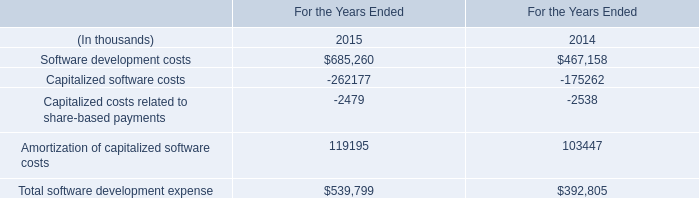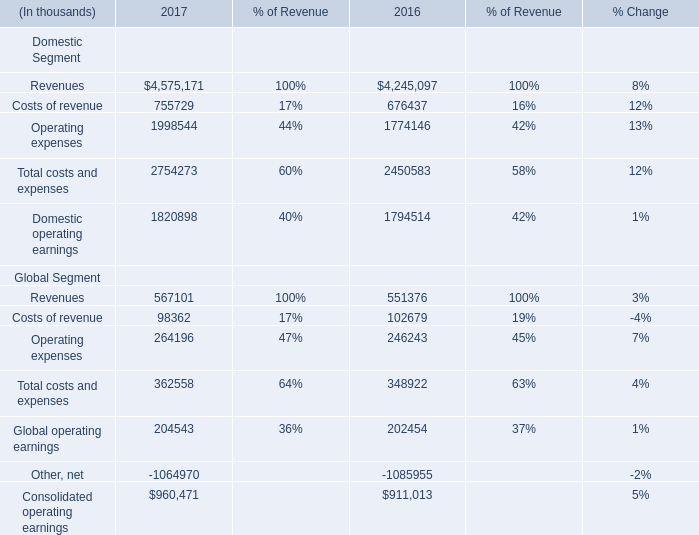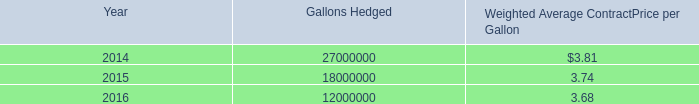What's the sum of Software development costs of For the Years Ended 2014, Operating expenses Global Segment of 2016, and Global operating earnings Global Segment of 2016 ? 
Computations: ((467158.0 + 246243.0) + 202454.0)
Answer: 915855.0. 